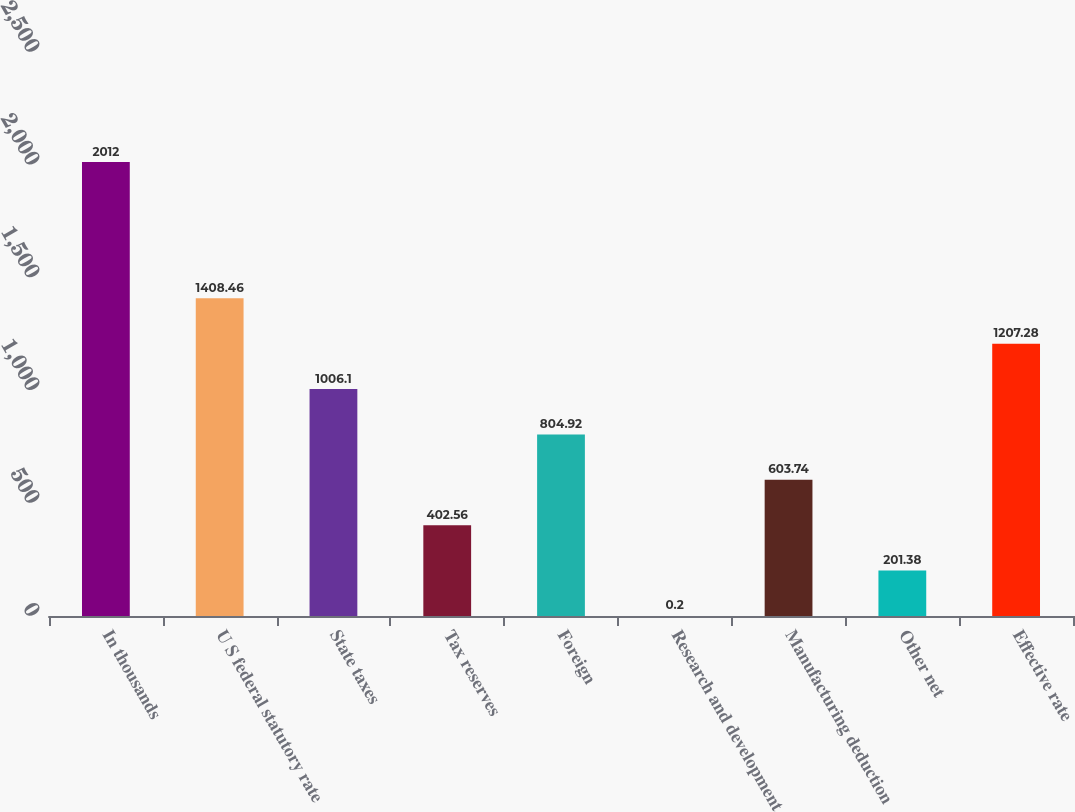Convert chart. <chart><loc_0><loc_0><loc_500><loc_500><bar_chart><fcel>In thousands<fcel>U S federal statutory rate<fcel>State taxes<fcel>Tax reserves<fcel>Foreign<fcel>Research and development<fcel>Manufacturing deduction<fcel>Other net<fcel>Effective rate<nl><fcel>2012<fcel>1408.46<fcel>1006.1<fcel>402.56<fcel>804.92<fcel>0.2<fcel>603.74<fcel>201.38<fcel>1207.28<nl></chart> 